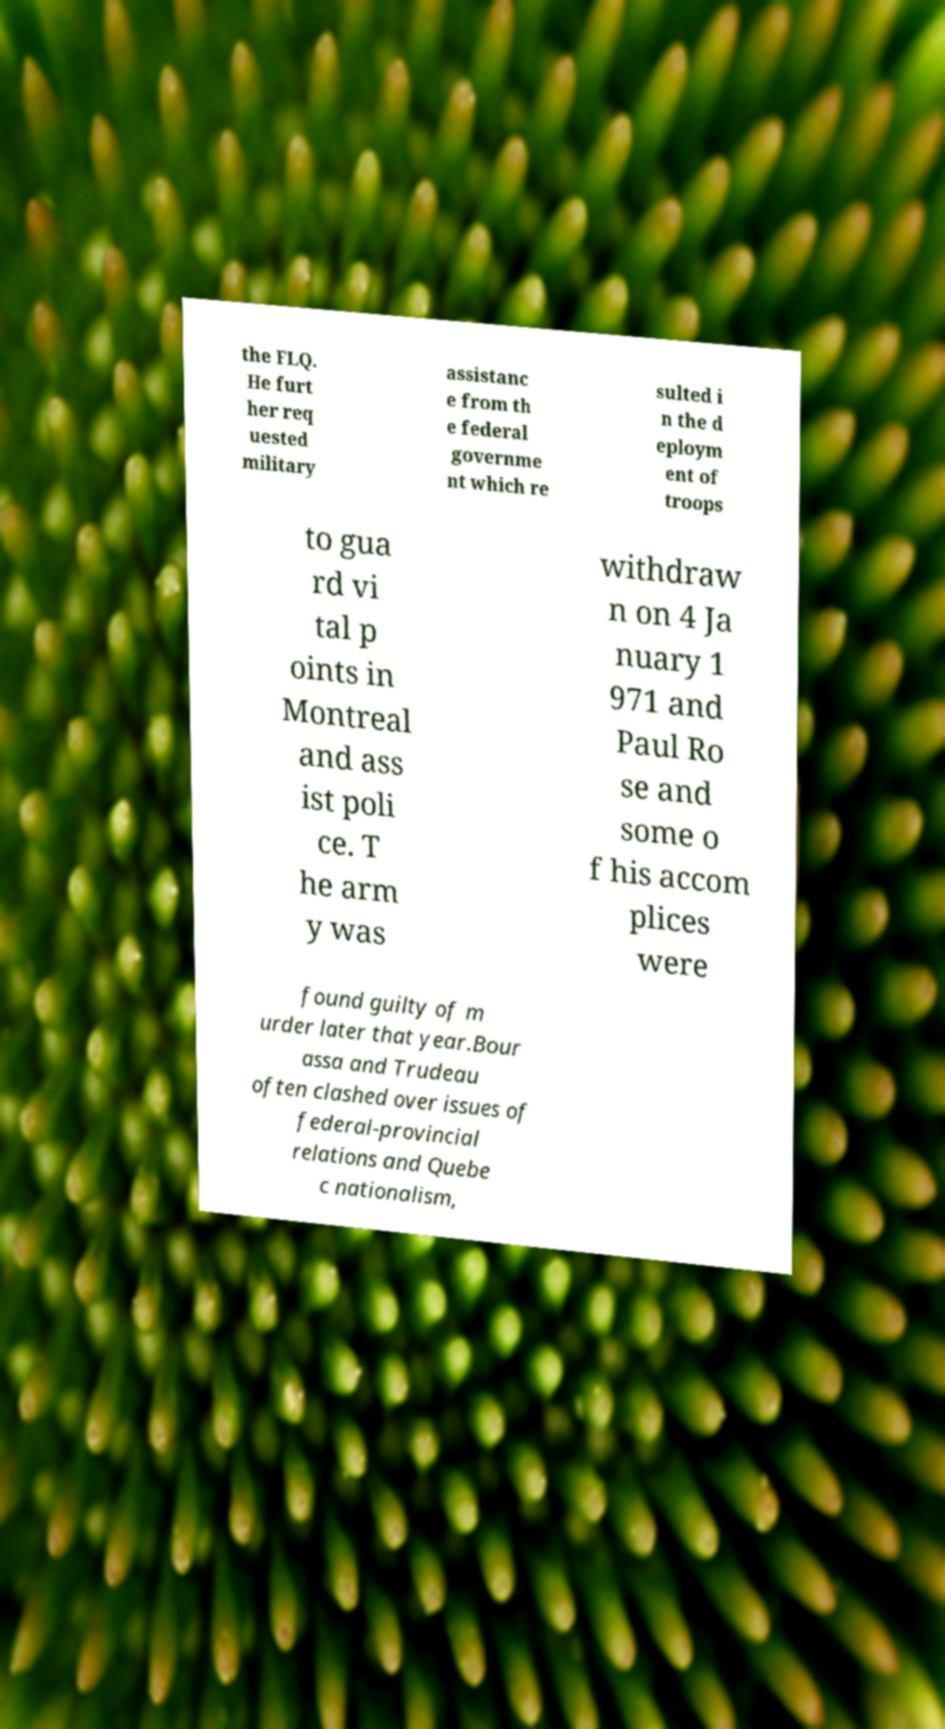Please read and relay the text visible in this image. What does it say? the FLQ. He furt her req uested military assistanc e from th e federal governme nt which re sulted i n the d eploym ent of troops to gua rd vi tal p oints in Montreal and ass ist poli ce. T he arm y was withdraw n on 4 Ja nuary 1 971 and Paul Ro se and some o f his accom plices were found guilty of m urder later that year.Bour assa and Trudeau often clashed over issues of federal-provincial relations and Quebe c nationalism, 